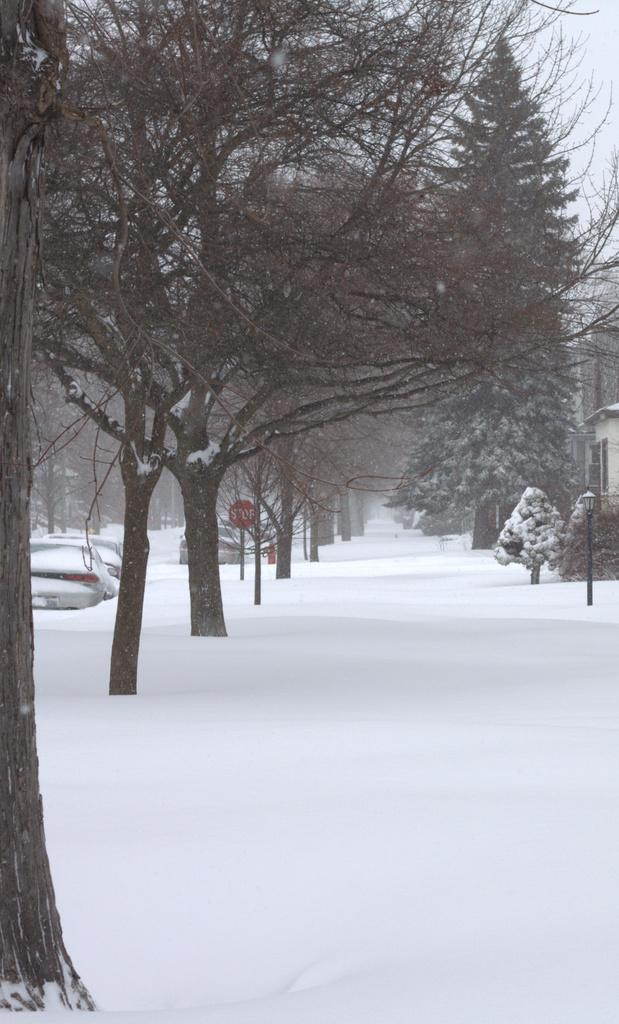What type of natural elements can be seen in the image? There are trees in the image. What man-made structures are present in the image? There are poles, a light, a board, a building, and cars in the image. What is the weather condition in the image? There is snow visible in the image, indicating a cold or wintery condition. What type of cable is being used by the coach in the image? There is no coach or cable present in the image. 